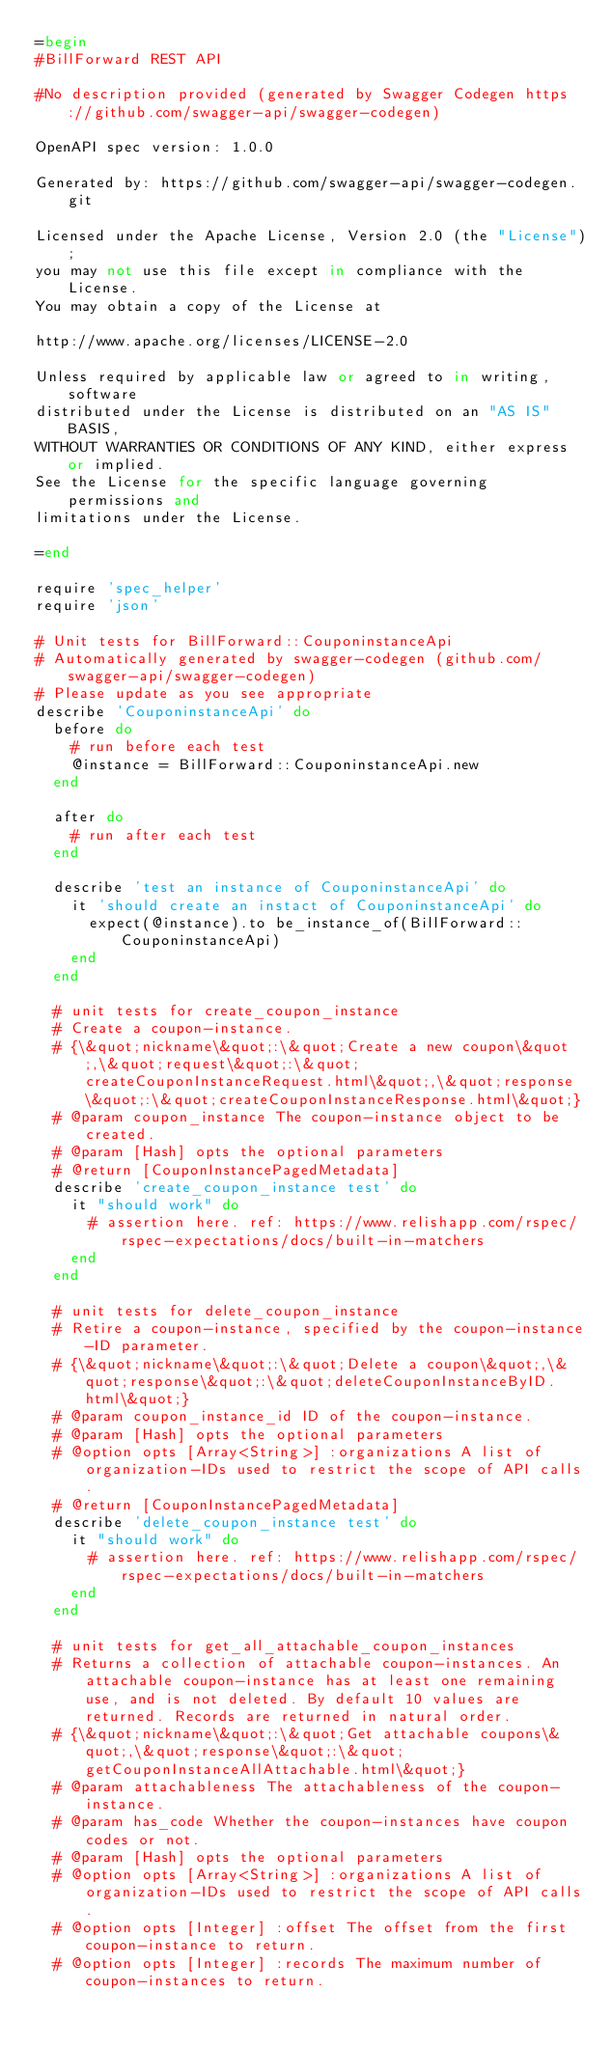Convert code to text. <code><loc_0><loc_0><loc_500><loc_500><_Ruby_>=begin
#BillForward REST API

#No description provided (generated by Swagger Codegen https://github.com/swagger-api/swagger-codegen)

OpenAPI spec version: 1.0.0

Generated by: https://github.com/swagger-api/swagger-codegen.git

Licensed under the Apache License, Version 2.0 (the "License");
you may not use this file except in compliance with the License.
You may obtain a copy of the License at

http://www.apache.org/licenses/LICENSE-2.0

Unless required by applicable law or agreed to in writing, software
distributed under the License is distributed on an "AS IS" BASIS,
WITHOUT WARRANTIES OR CONDITIONS OF ANY KIND, either express or implied.
See the License for the specific language governing permissions and
limitations under the License.

=end

require 'spec_helper'
require 'json'

# Unit tests for BillForward::CouponinstanceApi
# Automatically generated by swagger-codegen (github.com/swagger-api/swagger-codegen)
# Please update as you see appropriate
describe 'CouponinstanceApi' do
  before do
    # run before each test
    @instance = BillForward::CouponinstanceApi.new
  end

  after do
    # run after each test
  end

  describe 'test an instance of CouponinstanceApi' do
    it 'should create an instact of CouponinstanceApi' do
      expect(@instance).to be_instance_of(BillForward::CouponinstanceApi)
    end
  end

  # unit tests for create_coupon_instance
  # Create a coupon-instance.
  # {\&quot;nickname\&quot;:\&quot;Create a new coupon\&quot;,\&quot;request\&quot;:\&quot;createCouponInstanceRequest.html\&quot;,\&quot;response\&quot;:\&quot;createCouponInstanceResponse.html\&quot;}
  # @param coupon_instance The coupon-instance object to be created.
  # @param [Hash] opts the optional parameters
  # @return [CouponInstancePagedMetadata]
  describe 'create_coupon_instance test' do
    it "should work" do
      # assertion here. ref: https://www.relishapp.com/rspec/rspec-expectations/docs/built-in-matchers
    end
  end

  # unit tests for delete_coupon_instance
  # Retire a coupon-instance, specified by the coupon-instance-ID parameter.
  # {\&quot;nickname\&quot;:\&quot;Delete a coupon\&quot;,\&quot;response\&quot;:\&quot;deleteCouponInstanceByID.html\&quot;}
  # @param coupon_instance_id ID of the coupon-instance.
  # @param [Hash] opts the optional parameters
  # @option opts [Array<String>] :organizations A list of organization-IDs used to restrict the scope of API calls.
  # @return [CouponInstancePagedMetadata]
  describe 'delete_coupon_instance test' do
    it "should work" do
      # assertion here. ref: https://www.relishapp.com/rspec/rspec-expectations/docs/built-in-matchers
    end
  end

  # unit tests for get_all_attachable_coupon_instances
  # Returns a collection of attachable coupon-instances. An attachable coupon-instance has at least one remaining use, and is not deleted. By default 10 values are returned. Records are returned in natural order.
  # {\&quot;nickname\&quot;:\&quot;Get attachable coupons\&quot;,\&quot;response\&quot;:\&quot;getCouponInstanceAllAttachable.html\&quot;}
  # @param attachableness The attachableness of the coupon-instance.
  # @param has_code Whether the coupon-instances have coupon codes or not.
  # @param [Hash] opts the optional parameters
  # @option opts [Array<String>] :organizations A list of organization-IDs used to restrict the scope of API calls.
  # @option opts [Integer] :offset The offset from the first coupon-instance to return.
  # @option opts [Integer] :records The maximum number of coupon-instances to return.</code> 